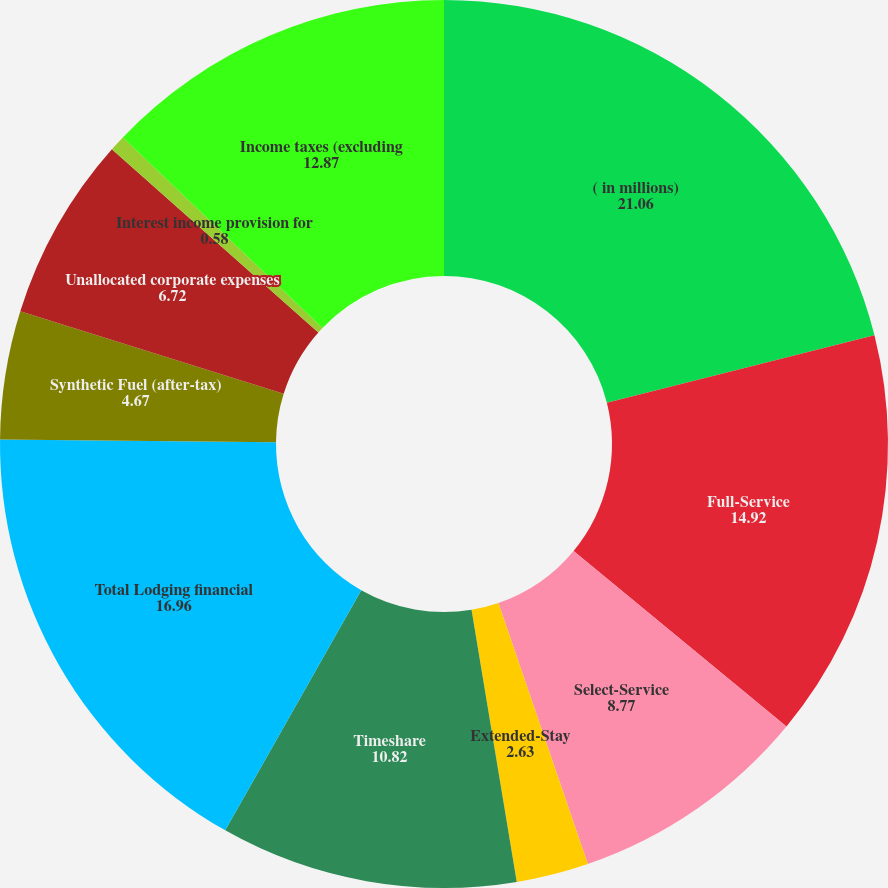Convert chart. <chart><loc_0><loc_0><loc_500><loc_500><pie_chart><fcel>( in millions)<fcel>Full-Service<fcel>Select-Service<fcel>Extended-Stay<fcel>Timeshare<fcel>Total Lodging financial<fcel>Synthetic Fuel (after-tax)<fcel>Unallocated corporate expenses<fcel>Interest income provision for<fcel>Income taxes (excluding<nl><fcel>21.06%<fcel>14.92%<fcel>8.77%<fcel>2.63%<fcel>10.82%<fcel>16.96%<fcel>4.67%<fcel>6.72%<fcel>0.58%<fcel>12.87%<nl></chart> 